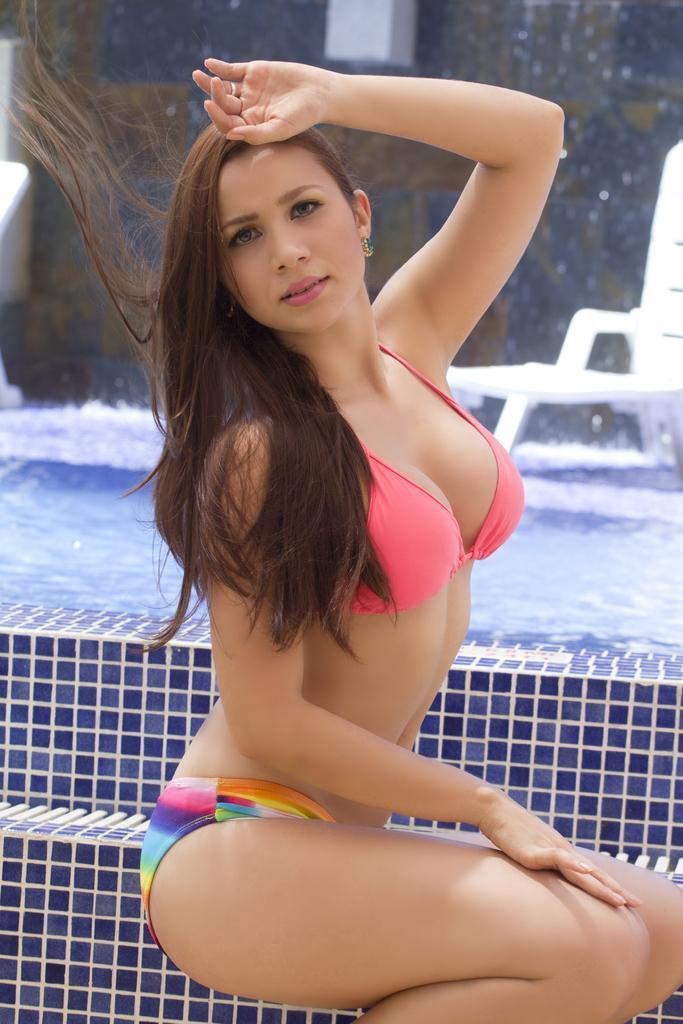Can you describe this image briefly? In the image we can see there is a woman sitting on the floor and behind there is a swimming pool. 